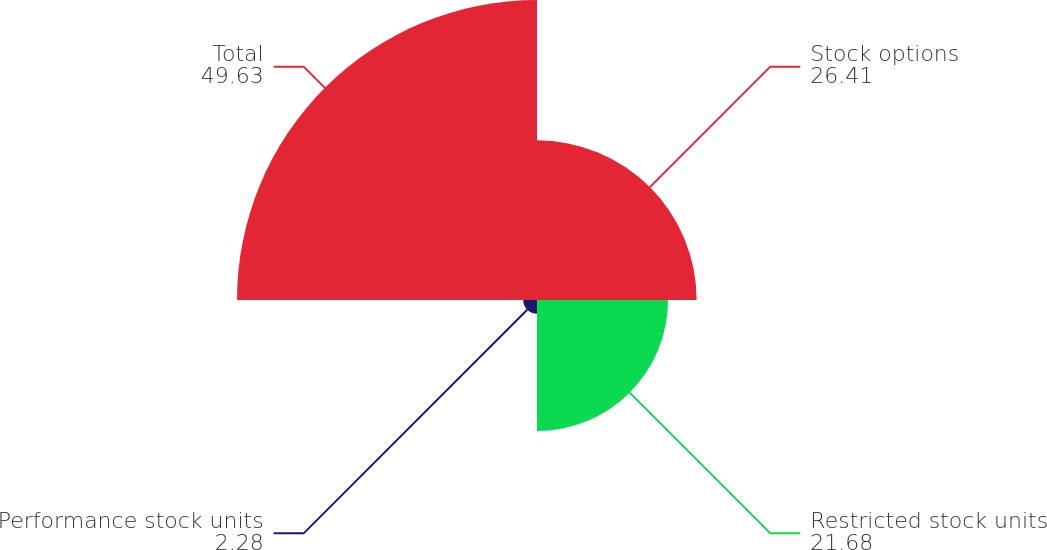Convert chart to OTSL. <chart><loc_0><loc_0><loc_500><loc_500><pie_chart><fcel>Stock options<fcel>Restricted stock units<fcel>Performance stock units<fcel>Total<nl><fcel>26.41%<fcel>21.68%<fcel>2.28%<fcel>49.63%<nl></chart> 